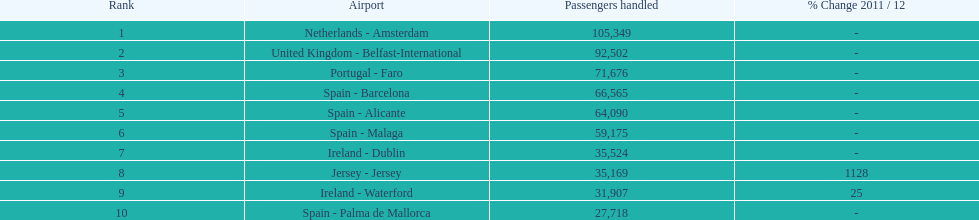How many passengers were handled in an airport in spain? 217,548. 